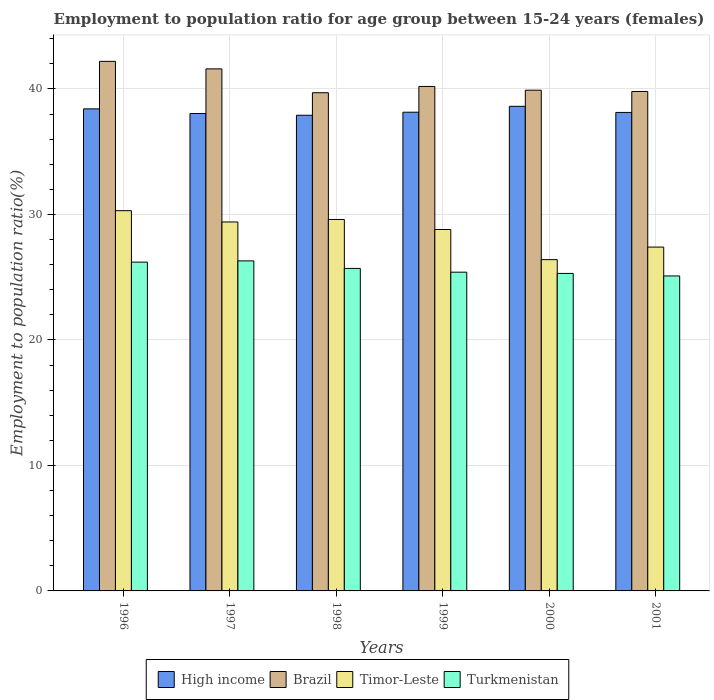How many different coloured bars are there?
Provide a short and direct response. 4. How many groups of bars are there?
Your answer should be very brief. 6. Are the number of bars on each tick of the X-axis equal?
Keep it short and to the point. Yes. How many bars are there on the 5th tick from the right?
Offer a terse response. 4. What is the employment to population ratio in Brazil in 2000?
Offer a terse response. 39.9. Across all years, what is the maximum employment to population ratio in Timor-Leste?
Offer a terse response. 30.3. Across all years, what is the minimum employment to population ratio in Timor-Leste?
Ensure brevity in your answer.  26.4. What is the total employment to population ratio in Brazil in the graph?
Ensure brevity in your answer.  243.4. What is the difference between the employment to population ratio in Turkmenistan in 1999 and that in 2001?
Give a very brief answer. 0.3. What is the difference between the employment to population ratio in High income in 2001 and the employment to population ratio in Brazil in 1999?
Your answer should be very brief. -2.07. What is the average employment to population ratio in Turkmenistan per year?
Make the answer very short. 25.67. In the year 1997, what is the difference between the employment to population ratio in Brazil and employment to population ratio in Turkmenistan?
Provide a succinct answer. 15.3. In how many years, is the employment to population ratio in Turkmenistan greater than 34 %?
Your response must be concise. 0. What is the ratio of the employment to population ratio in Timor-Leste in 1998 to that in 1999?
Ensure brevity in your answer.  1.03. Is the difference between the employment to population ratio in Brazil in 1998 and 2000 greater than the difference between the employment to population ratio in Turkmenistan in 1998 and 2000?
Give a very brief answer. No. What is the difference between the highest and the second highest employment to population ratio in Brazil?
Keep it short and to the point. 0.6. What is the difference between the highest and the lowest employment to population ratio in Brazil?
Offer a very short reply. 2.5. In how many years, is the employment to population ratio in High income greater than the average employment to population ratio in High income taken over all years?
Make the answer very short. 2. What does the 2nd bar from the right in 1999 represents?
Offer a very short reply. Timor-Leste. Are all the bars in the graph horizontal?
Ensure brevity in your answer.  No. How many years are there in the graph?
Give a very brief answer. 6. Does the graph contain grids?
Your response must be concise. Yes. Where does the legend appear in the graph?
Your response must be concise. Bottom center. How many legend labels are there?
Offer a terse response. 4. What is the title of the graph?
Your answer should be compact. Employment to population ratio for age group between 15-24 years (females). Does "Latin America(developing only)" appear as one of the legend labels in the graph?
Your response must be concise. No. What is the label or title of the X-axis?
Make the answer very short. Years. What is the label or title of the Y-axis?
Your answer should be compact. Employment to population ratio(%). What is the Employment to population ratio(%) of High income in 1996?
Your response must be concise. 38.41. What is the Employment to population ratio(%) of Brazil in 1996?
Make the answer very short. 42.2. What is the Employment to population ratio(%) of Timor-Leste in 1996?
Give a very brief answer. 30.3. What is the Employment to population ratio(%) in Turkmenistan in 1996?
Provide a short and direct response. 26.2. What is the Employment to population ratio(%) of High income in 1997?
Provide a short and direct response. 38.04. What is the Employment to population ratio(%) in Brazil in 1997?
Your answer should be very brief. 41.6. What is the Employment to population ratio(%) of Timor-Leste in 1997?
Your answer should be compact. 29.4. What is the Employment to population ratio(%) of Turkmenistan in 1997?
Your answer should be compact. 26.3. What is the Employment to population ratio(%) in High income in 1998?
Provide a short and direct response. 37.9. What is the Employment to population ratio(%) in Brazil in 1998?
Give a very brief answer. 39.7. What is the Employment to population ratio(%) of Timor-Leste in 1998?
Offer a terse response. 29.6. What is the Employment to population ratio(%) of Turkmenistan in 1998?
Keep it short and to the point. 25.7. What is the Employment to population ratio(%) in High income in 1999?
Offer a terse response. 38.15. What is the Employment to population ratio(%) in Brazil in 1999?
Offer a terse response. 40.2. What is the Employment to population ratio(%) in Timor-Leste in 1999?
Make the answer very short. 28.8. What is the Employment to population ratio(%) in Turkmenistan in 1999?
Offer a very short reply. 25.4. What is the Employment to population ratio(%) of High income in 2000?
Your answer should be very brief. 38.62. What is the Employment to population ratio(%) in Brazil in 2000?
Provide a short and direct response. 39.9. What is the Employment to population ratio(%) in Timor-Leste in 2000?
Offer a very short reply. 26.4. What is the Employment to population ratio(%) of Turkmenistan in 2000?
Make the answer very short. 25.3. What is the Employment to population ratio(%) in High income in 2001?
Your answer should be compact. 38.13. What is the Employment to population ratio(%) of Brazil in 2001?
Your response must be concise. 39.8. What is the Employment to population ratio(%) in Timor-Leste in 2001?
Provide a succinct answer. 27.4. What is the Employment to population ratio(%) of Turkmenistan in 2001?
Provide a succinct answer. 25.1. Across all years, what is the maximum Employment to population ratio(%) of High income?
Ensure brevity in your answer.  38.62. Across all years, what is the maximum Employment to population ratio(%) in Brazil?
Make the answer very short. 42.2. Across all years, what is the maximum Employment to population ratio(%) of Timor-Leste?
Make the answer very short. 30.3. Across all years, what is the maximum Employment to population ratio(%) in Turkmenistan?
Your response must be concise. 26.3. Across all years, what is the minimum Employment to population ratio(%) of High income?
Provide a short and direct response. 37.9. Across all years, what is the minimum Employment to population ratio(%) of Brazil?
Your answer should be very brief. 39.7. Across all years, what is the minimum Employment to population ratio(%) in Timor-Leste?
Your answer should be very brief. 26.4. Across all years, what is the minimum Employment to population ratio(%) of Turkmenistan?
Ensure brevity in your answer.  25.1. What is the total Employment to population ratio(%) of High income in the graph?
Offer a terse response. 229.26. What is the total Employment to population ratio(%) of Brazil in the graph?
Make the answer very short. 243.4. What is the total Employment to population ratio(%) of Timor-Leste in the graph?
Offer a very short reply. 171.9. What is the total Employment to population ratio(%) of Turkmenistan in the graph?
Your response must be concise. 154. What is the difference between the Employment to population ratio(%) of High income in 1996 and that in 1997?
Provide a succinct answer. 0.37. What is the difference between the Employment to population ratio(%) of Timor-Leste in 1996 and that in 1997?
Offer a terse response. 0.9. What is the difference between the Employment to population ratio(%) in Turkmenistan in 1996 and that in 1997?
Your answer should be very brief. -0.1. What is the difference between the Employment to population ratio(%) in High income in 1996 and that in 1998?
Offer a terse response. 0.51. What is the difference between the Employment to population ratio(%) of Turkmenistan in 1996 and that in 1998?
Offer a terse response. 0.5. What is the difference between the Employment to population ratio(%) of High income in 1996 and that in 1999?
Provide a short and direct response. 0.27. What is the difference between the Employment to population ratio(%) of Timor-Leste in 1996 and that in 1999?
Keep it short and to the point. 1.5. What is the difference between the Employment to population ratio(%) of High income in 1996 and that in 2000?
Provide a short and direct response. -0.2. What is the difference between the Employment to population ratio(%) of Brazil in 1996 and that in 2000?
Offer a terse response. 2.3. What is the difference between the Employment to population ratio(%) of High income in 1996 and that in 2001?
Ensure brevity in your answer.  0.28. What is the difference between the Employment to population ratio(%) in Timor-Leste in 1996 and that in 2001?
Your response must be concise. 2.9. What is the difference between the Employment to population ratio(%) in Turkmenistan in 1996 and that in 2001?
Keep it short and to the point. 1.1. What is the difference between the Employment to population ratio(%) of High income in 1997 and that in 1998?
Offer a very short reply. 0.14. What is the difference between the Employment to population ratio(%) in High income in 1997 and that in 1999?
Keep it short and to the point. -0.1. What is the difference between the Employment to population ratio(%) of Brazil in 1997 and that in 1999?
Your answer should be compact. 1.4. What is the difference between the Employment to population ratio(%) in Timor-Leste in 1997 and that in 1999?
Make the answer very short. 0.6. What is the difference between the Employment to population ratio(%) of High income in 1997 and that in 2000?
Offer a very short reply. -0.57. What is the difference between the Employment to population ratio(%) of Timor-Leste in 1997 and that in 2000?
Your answer should be compact. 3. What is the difference between the Employment to population ratio(%) of Turkmenistan in 1997 and that in 2000?
Offer a terse response. 1. What is the difference between the Employment to population ratio(%) in High income in 1997 and that in 2001?
Your answer should be compact. -0.09. What is the difference between the Employment to population ratio(%) in Turkmenistan in 1997 and that in 2001?
Your answer should be compact. 1.2. What is the difference between the Employment to population ratio(%) of High income in 1998 and that in 1999?
Make the answer very short. -0.24. What is the difference between the Employment to population ratio(%) in Timor-Leste in 1998 and that in 1999?
Ensure brevity in your answer.  0.8. What is the difference between the Employment to population ratio(%) in High income in 1998 and that in 2000?
Give a very brief answer. -0.71. What is the difference between the Employment to population ratio(%) in High income in 1998 and that in 2001?
Your response must be concise. -0.23. What is the difference between the Employment to population ratio(%) of Timor-Leste in 1998 and that in 2001?
Offer a terse response. 2.2. What is the difference between the Employment to population ratio(%) of Turkmenistan in 1998 and that in 2001?
Your answer should be compact. 0.6. What is the difference between the Employment to population ratio(%) in High income in 1999 and that in 2000?
Keep it short and to the point. -0.47. What is the difference between the Employment to population ratio(%) in Brazil in 1999 and that in 2000?
Give a very brief answer. 0.3. What is the difference between the Employment to population ratio(%) of High income in 1999 and that in 2001?
Make the answer very short. 0.02. What is the difference between the Employment to population ratio(%) of Brazil in 1999 and that in 2001?
Make the answer very short. 0.4. What is the difference between the Employment to population ratio(%) of Timor-Leste in 1999 and that in 2001?
Offer a terse response. 1.4. What is the difference between the Employment to population ratio(%) of High income in 2000 and that in 2001?
Provide a succinct answer. 0.49. What is the difference between the Employment to population ratio(%) in Brazil in 2000 and that in 2001?
Provide a succinct answer. 0.1. What is the difference between the Employment to population ratio(%) in Turkmenistan in 2000 and that in 2001?
Your response must be concise. 0.2. What is the difference between the Employment to population ratio(%) in High income in 1996 and the Employment to population ratio(%) in Brazil in 1997?
Give a very brief answer. -3.19. What is the difference between the Employment to population ratio(%) in High income in 1996 and the Employment to population ratio(%) in Timor-Leste in 1997?
Your response must be concise. 9.01. What is the difference between the Employment to population ratio(%) in High income in 1996 and the Employment to population ratio(%) in Turkmenistan in 1997?
Provide a short and direct response. 12.11. What is the difference between the Employment to population ratio(%) in Brazil in 1996 and the Employment to population ratio(%) in Turkmenistan in 1997?
Your answer should be very brief. 15.9. What is the difference between the Employment to population ratio(%) in High income in 1996 and the Employment to population ratio(%) in Brazil in 1998?
Offer a terse response. -1.29. What is the difference between the Employment to population ratio(%) of High income in 1996 and the Employment to population ratio(%) of Timor-Leste in 1998?
Offer a very short reply. 8.81. What is the difference between the Employment to population ratio(%) of High income in 1996 and the Employment to population ratio(%) of Turkmenistan in 1998?
Give a very brief answer. 12.71. What is the difference between the Employment to population ratio(%) of Brazil in 1996 and the Employment to population ratio(%) of Timor-Leste in 1998?
Offer a very short reply. 12.6. What is the difference between the Employment to population ratio(%) of Brazil in 1996 and the Employment to population ratio(%) of Turkmenistan in 1998?
Give a very brief answer. 16.5. What is the difference between the Employment to population ratio(%) of Timor-Leste in 1996 and the Employment to population ratio(%) of Turkmenistan in 1998?
Provide a short and direct response. 4.6. What is the difference between the Employment to population ratio(%) of High income in 1996 and the Employment to population ratio(%) of Brazil in 1999?
Your answer should be compact. -1.79. What is the difference between the Employment to population ratio(%) in High income in 1996 and the Employment to population ratio(%) in Timor-Leste in 1999?
Your answer should be very brief. 9.61. What is the difference between the Employment to population ratio(%) of High income in 1996 and the Employment to population ratio(%) of Turkmenistan in 1999?
Offer a very short reply. 13.01. What is the difference between the Employment to population ratio(%) in Brazil in 1996 and the Employment to population ratio(%) in Timor-Leste in 1999?
Provide a succinct answer. 13.4. What is the difference between the Employment to population ratio(%) of Timor-Leste in 1996 and the Employment to population ratio(%) of Turkmenistan in 1999?
Ensure brevity in your answer.  4.9. What is the difference between the Employment to population ratio(%) in High income in 1996 and the Employment to population ratio(%) in Brazil in 2000?
Your answer should be very brief. -1.49. What is the difference between the Employment to population ratio(%) in High income in 1996 and the Employment to population ratio(%) in Timor-Leste in 2000?
Offer a very short reply. 12.01. What is the difference between the Employment to population ratio(%) in High income in 1996 and the Employment to population ratio(%) in Turkmenistan in 2000?
Provide a succinct answer. 13.11. What is the difference between the Employment to population ratio(%) in Brazil in 1996 and the Employment to population ratio(%) in Timor-Leste in 2000?
Make the answer very short. 15.8. What is the difference between the Employment to population ratio(%) in High income in 1996 and the Employment to population ratio(%) in Brazil in 2001?
Provide a succinct answer. -1.39. What is the difference between the Employment to population ratio(%) in High income in 1996 and the Employment to population ratio(%) in Timor-Leste in 2001?
Ensure brevity in your answer.  11.01. What is the difference between the Employment to population ratio(%) of High income in 1996 and the Employment to population ratio(%) of Turkmenistan in 2001?
Ensure brevity in your answer.  13.31. What is the difference between the Employment to population ratio(%) in Brazil in 1996 and the Employment to population ratio(%) in Timor-Leste in 2001?
Offer a terse response. 14.8. What is the difference between the Employment to population ratio(%) of Brazil in 1996 and the Employment to population ratio(%) of Turkmenistan in 2001?
Your response must be concise. 17.1. What is the difference between the Employment to population ratio(%) in High income in 1997 and the Employment to population ratio(%) in Brazil in 1998?
Your answer should be compact. -1.66. What is the difference between the Employment to population ratio(%) of High income in 1997 and the Employment to population ratio(%) of Timor-Leste in 1998?
Offer a very short reply. 8.44. What is the difference between the Employment to population ratio(%) of High income in 1997 and the Employment to population ratio(%) of Turkmenistan in 1998?
Make the answer very short. 12.34. What is the difference between the Employment to population ratio(%) of Brazil in 1997 and the Employment to population ratio(%) of Turkmenistan in 1998?
Keep it short and to the point. 15.9. What is the difference between the Employment to population ratio(%) of High income in 1997 and the Employment to population ratio(%) of Brazil in 1999?
Offer a very short reply. -2.16. What is the difference between the Employment to population ratio(%) of High income in 1997 and the Employment to population ratio(%) of Timor-Leste in 1999?
Make the answer very short. 9.24. What is the difference between the Employment to population ratio(%) in High income in 1997 and the Employment to population ratio(%) in Turkmenistan in 1999?
Provide a succinct answer. 12.64. What is the difference between the Employment to population ratio(%) of Brazil in 1997 and the Employment to population ratio(%) of Turkmenistan in 1999?
Give a very brief answer. 16.2. What is the difference between the Employment to population ratio(%) in High income in 1997 and the Employment to population ratio(%) in Brazil in 2000?
Your answer should be very brief. -1.86. What is the difference between the Employment to population ratio(%) of High income in 1997 and the Employment to population ratio(%) of Timor-Leste in 2000?
Give a very brief answer. 11.64. What is the difference between the Employment to population ratio(%) in High income in 1997 and the Employment to population ratio(%) in Turkmenistan in 2000?
Provide a short and direct response. 12.74. What is the difference between the Employment to population ratio(%) in Brazil in 1997 and the Employment to population ratio(%) in Timor-Leste in 2000?
Provide a short and direct response. 15.2. What is the difference between the Employment to population ratio(%) in Brazil in 1997 and the Employment to population ratio(%) in Turkmenistan in 2000?
Keep it short and to the point. 16.3. What is the difference between the Employment to population ratio(%) of High income in 1997 and the Employment to population ratio(%) of Brazil in 2001?
Your answer should be compact. -1.76. What is the difference between the Employment to population ratio(%) of High income in 1997 and the Employment to population ratio(%) of Timor-Leste in 2001?
Ensure brevity in your answer.  10.64. What is the difference between the Employment to population ratio(%) of High income in 1997 and the Employment to population ratio(%) of Turkmenistan in 2001?
Keep it short and to the point. 12.94. What is the difference between the Employment to population ratio(%) in Brazil in 1997 and the Employment to population ratio(%) in Timor-Leste in 2001?
Your answer should be very brief. 14.2. What is the difference between the Employment to population ratio(%) in Timor-Leste in 1997 and the Employment to population ratio(%) in Turkmenistan in 2001?
Offer a terse response. 4.3. What is the difference between the Employment to population ratio(%) in High income in 1998 and the Employment to population ratio(%) in Brazil in 1999?
Provide a succinct answer. -2.3. What is the difference between the Employment to population ratio(%) in High income in 1998 and the Employment to population ratio(%) in Timor-Leste in 1999?
Offer a very short reply. 9.1. What is the difference between the Employment to population ratio(%) of High income in 1998 and the Employment to population ratio(%) of Turkmenistan in 1999?
Your answer should be very brief. 12.5. What is the difference between the Employment to population ratio(%) of Brazil in 1998 and the Employment to population ratio(%) of Timor-Leste in 1999?
Ensure brevity in your answer.  10.9. What is the difference between the Employment to population ratio(%) in Brazil in 1998 and the Employment to population ratio(%) in Turkmenistan in 1999?
Your answer should be very brief. 14.3. What is the difference between the Employment to population ratio(%) of High income in 1998 and the Employment to population ratio(%) of Brazil in 2000?
Your response must be concise. -2. What is the difference between the Employment to population ratio(%) in High income in 1998 and the Employment to population ratio(%) in Timor-Leste in 2000?
Offer a very short reply. 11.5. What is the difference between the Employment to population ratio(%) in High income in 1998 and the Employment to population ratio(%) in Turkmenistan in 2000?
Keep it short and to the point. 12.6. What is the difference between the Employment to population ratio(%) in High income in 1998 and the Employment to population ratio(%) in Brazil in 2001?
Your answer should be compact. -1.9. What is the difference between the Employment to population ratio(%) in High income in 1998 and the Employment to population ratio(%) in Timor-Leste in 2001?
Offer a terse response. 10.5. What is the difference between the Employment to population ratio(%) of High income in 1998 and the Employment to population ratio(%) of Turkmenistan in 2001?
Provide a succinct answer. 12.8. What is the difference between the Employment to population ratio(%) of High income in 1999 and the Employment to population ratio(%) of Brazil in 2000?
Ensure brevity in your answer.  -1.75. What is the difference between the Employment to population ratio(%) in High income in 1999 and the Employment to population ratio(%) in Timor-Leste in 2000?
Provide a short and direct response. 11.75. What is the difference between the Employment to population ratio(%) in High income in 1999 and the Employment to population ratio(%) in Turkmenistan in 2000?
Offer a terse response. 12.85. What is the difference between the Employment to population ratio(%) in High income in 1999 and the Employment to population ratio(%) in Brazil in 2001?
Your answer should be very brief. -1.65. What is the difference between the Employment to population ratio(%) of High income in 1999 and the Employment to population ratio(%) of Timor-Leste in 2001?
Offer a very short reply. 10.75. What is the difference between the Employment to population ratio(%) in High income in 1999 and the Employment to population ratio(%) in Turkmenistan in 2001?
Make the answer very short. 13.05. What is the difference between the Employment to population ratio(%) in Brazil in 1999 and the Employment to population ratio(%) in Timor-Leste in 2001?
Offer a very short reply. 12.8. What is the difference between the Employment to population ratio(%) in Brazil in 1999 and the Employment to population ratio(%) in Turkmenistan in 2001?
Make the answer very short. 15.1. What is the difference between the Employment to population ratio(%) of Timor-Leste in 1999 and the Employment to population ratio(%) of Turkmenistan in 2001?
Your response must be concise. 3.7. What is the difference between the Employment to population ratio(%) of High income in 2000 and the Employment to population ratio(%) of Brazil in 2001?
Offer a very short reply. -1.18. What is the difference between the Employment to population ratio(%) of High income in 2000 and the Employment to population ratio(%) of Timor-Leste in 2001?
Give a very brief answer. 11.22. What is the difference between the Employment to population ratio(%) in High income in 2000 and the Employment to population ratio(%) in Turkmenistan in 2001?
Make the answer very short. 13.52. What is the difference between the Employment to population ratio(%) of Timor-Leste in 2000 and the Employment to population ratio(%) of Turkmenistan in 2001?
Offer a terse response. 1.3. What is the average Employment to population ratio(%) in High income per year?
Offer a very short reply. 38.21. What is the average Employment to population ratio(%) in Brazil per year?
Your answer should be compact. 40.57. What is the average Employment to population ratio(%) in Timor-Leste per year?
Offer a terse response. 28.65. What is the average Employment to population ratio(%) of Turkmenistan per year?
Provide a succinct answer. 25.67. In the year 1996, what is the difference between the Employment to population ratio(%) of High income and Employment to population ratio(%) of Brazil?
Provide a succinct answer. -3.79. In the year 1996, what is the difference between the Employment to population ratio(%) in High income and Employment to population ratio(%) in Timor-Leste?
Offer a terse response. 8.11. In the year 1996, what is the difference between the Employment to population ratio(%) in High income and Employment to population ratio(%) in Turkmenistan?
Offer a terse response. 12.21. In the year 1996, what is the difference between the Employment to population ratio(%) in Brazil and Employment to population ratio(%) in Timor-Leste?
Your answer should be compact. 11.9. In the year 1996, what is the difference between the Employment to population ratio(%) of Brazil and Employment to population ratio(%) of Turkmenistan?
Your answer should be compact. 16. In the year 1996, what is the difference between the Employment to population ratio(%) of Timor-Leste and Employment to population ratio(%) of Turkmenistan?
Offer a terse response. 4.1. In the year 1997, what is the difference between the Employment to population ratio(%) of High income and Employment to population ratio(%) of Brazil?
Your answer should be very brief. -3.56. In the year 1997, what is the difference between the Employment to population ratio(%) in High income and Employment to population ratio(%) in Timor-Leste?
Provide a short and direct response. 8.64. In the year 1997, what is the difference between the Employment to population ratio(%) of High income and Employment to population ratio(%) of Turkmenistan?
Offer a very short reply. 11.74. In the year 1997, what is the difference between the Employment to population ratio(%) in Brazil and Employment to population ratio(%) in Turkmenistan?
Keep it short and to the point. 15.3. In the year 1998, what is the difference between the Employment to population ratio(%) in High income and Employment to population ratio(%) in Brazil?
Provide a short and direct response. -1.8. In the year 1998, what is the difference between the Employment to population ratio(%) of High income and Employment to population ratio(%) of Timor-Leste?
Give a very brief answer. 8.3. In the year 1998, what is the difference between the Employment to population ratio(%) in High income and Employment to population ratio(%) in Turkmenistan?
Your answer should be compact. 12.2. In the year 1998, what is the difference between the Employment to population ratio(%) in Brazil and Employment to population ratio(%) in Timor-Leste?
Your response must be concise. 10.1. In the year 1998, what is the difference between the Employment to population ratio(%) of Timor-Leste and Employment to population ratio(%) of Turkmenistan?
Offer a very short reply. 3.9. In the year 1999, what is the difference between the Employment to population ratio(%) of High income and Employment to population ratio(%) of Brazil?
Provide a short and direct response. -2.05. In the year 1999, what is the difference between the Employment to population ratio(%) in High income and Employment to population ratio(%) in Timor-Leste?
Your answer should be compact. 9.35. In the year 1999, what is the difference between the Employment to population ratio(%) in High income and Employment to population ratio(%) in Turkmenistan?
Provide a short and direct response. 12.75. In the year 2000, what is the difference between the Employment to population ratio(%) in High income and Employment to population ratio(%) in Brazil?
Offer a terse response. -1.28. In the year 2000, what is the difference between the Employment to population ratio(%) of High income and Employment to population ratio(%) of Timor-Leste?
Your response must be concise. 12.22. In the year 2000, what is the difference between the Employment to population ratio(%) in High income and Employment to population ratio(%) in Turkmenistan?
Your response must be concise. 13.32. In the year 2000, what is the difference between the Employment to population ratio(%) of Brazil and Employment to population ratio(%) of Turkmenistan?
Offer a very short reply. 14.6. In the year 2000, what is the difference between the Employment to population ratio(%) of Timor-Leste and Employment to population ratio(%) of Turkmenistan?
Provide a short and direct response. 1.1. In the year 2001, what is the difference between the Employment to population ratio(%) of High income and Employment to population ratio(%) of Brazil?
Keep it short and to the point. -1.67. In the year 2001, what is the difference between the Employment to population ratio(%) in High income and Employment to population ratio(%) in Timor-Leste?
Ensure brevity in your answer.  10.73. In the year 2001, what is the difference between the Employment to population ratio(%) in High income and Employment to population ratio(%) in Turkmenistan?
Provide a short and direct response. 13.03. In the year 2001, what is the difference between the Employment to population ratio(%) of Brazil and Employment to population ratio(%) of Timor-Leste?
Ensure brevity in your answer.  12.4. What is the ratio of the Employment to population ratio(%) of High income in 1996 to that in 1997?
Give a very brief answer. 1.01. What is the ratio of the Employment to population ratio(%) in Brazil in 1996 to that in 1997?
Offer a very short reply. 1.01. What is the ratio of the Employment to population ratio(%) in Timor-Leste in 1996 to that in 1997?
Offer a very short reply. 1.03. What is the ratio of the Employment to population ratio(%) of Turkmenistan in 1996 to that in 1997?
Provide a succinct answer. 1. What is the ratio of the Employment to population ratio(%) of High income in 1996 to that in 1998?
Keep it short and to the point. 1.01. What is the ratio of the Employment to population ratio(%) in Brazil in 1996 to that in 1998?
Provide a short and direct response. 1.06. What is the ratio of the Employment to population ratio(%) of Timor-Leste in 1996 to that in 1998?
Your response must be concise. 1.02. What is the ratio of the Employment to population ratio(%) of Turkmenistan in 1996 to that in 1998?
Your response must be concise. 1.02. What is the ratio of the Employment to population ratio(%) in Brazil in 1996 to that in 1999?
Give a very brief answer. 1.05. What is the ratio of the Employment to population ratio(%) in Timor-Leste in 1996 to that in 1999?
Ensure brevity in your answer.  1.05. What is the ratio of the Employment to population ratio(%) of Turkmenistan in 1996 to that in 1999?
Provide a succinct answer. 1.03. What is the ratio of the Employment to population ratio(%) of High income in 1996 to that in 2000?
Ensure brevity in your answer.  0.99. What is the ratio of the Employment to population ratio(%) of Brazil in 1996 to that in 2000?
Provide a succinct answer. 1.06. What is the ratio of the Employment to population ratio(%) of Timor-Leste in 1996 to that in 2000?
Keep it short and to the point. 1.15. What is the ratio of the Employment to population ratio(%) in Turkmenistan in 1996 to that in 2000?
Ensure brevity in your answer.  1.04. What is the ratio of the Employment to population ratio(%) of High income in 1996 to that in 2001?
Your answer should be very brief. 1.01. What is the ratio of the Employment to population ratio(%) in Brazil in 1996 to that in 2001?
Keep it short and to the point. 1.06. What is the ratio of the Employment to population ratio(%) of Timor-Leste in 1996 to that in 2001?
Your response must be concise. 1.11. What is the ratio of the Employment to population ratio(%) of Turkmenistan in 1996 to that in 2001?
Your response must be concise. 1.04. What is the ratio of the Employment to population ratio(%) in Brazil in 1997 to that in 1998?
Your response must be concise. 1.05. What is the ratio of the Employment to population ratio(%) in Timor-Leste in 1997 to that in 1998?
Offer a very short reply. 0.99. What is the ratio of the Employment to population ratio(%) in Turkmenistan in 1997 to that in 1998?
Make the answer very short. 1.02. What is the ratio of the Employment to population ratio(%) in High income in 1997 to that in 1999?
Your answer should be compact. 1. What is the ratio of the Employment to population ratio(%) in Brazil in 1997 to that in 1999?
Provide a short and direct response. 1.03. What is the ratio of the Employment to population ratio(%) in Timor-Leste in 1997 to that in 1999?
Provide a short and direct response. 1.02. What is the ratio of the Employment to population ratio(%) in Turkmenistan in 1997 to that in 1999?
Offer a terse response. 1.04. What is the ratio of the Employment to population ratio(%) in High income in 1997 to that in 2000?
Your answer should be compact. 0.99. What is the ratio of the Employment to population ratio(%) of Brazil in 1997 to that in 2000?
Offer a very short reply. 1.04. What is the ratio of the Employment to population ratio(%) of Timor-Leste in 1997 to that in 2000?
Ensure brevity in your answer.  1.11. What is the ratio of the Employment to population ratio(%) of Turkmenistan in 1997 to that in 2000?
Ensure brevity in your answer.  1.04. What is the ratio of the Employment to population ratio(%) of High income in 1997 to that in 2001?
Your answer should be very brief. 1. What is the ratio of the Employment to population ratio(%) of Brazil in 1997 to that in 2001?
Give a very brief answer. 1.05. What is the ratio of the Employment to population ratio(%) of Timor-Leste in 1997 to that in 2001?
Your answer should be very brief. 1.07. What is the ratio of the Employment to population ratio(%) of Turkmenistan in 1997 to that in 2001?
Make the answer very short. 1.05. What is the ratio of the Employment to population ratio(%) in High income in 1998 to that in 1999?
Your response must be concise. 0.99. What is the ratio of the Employment to population ratio(%) in Brazil in 1998 to that in 1999?
Provide a succinct answer. 0.99. What is the ratio of the Employment to population ratio(%) of Timor-Leste in 1998 to that in 1999?
Offer a terse response. 1.03. What is the ratio of the Employment to population ratio(%) in Turkmenistan in 1998 to that in 1999?
Your response must be concise. 1.01. What is the ratio of the Employment to population ratio(%) of High income in 1998 to that in 2000?
Your response must be concise. 0.98. What is the ratio of the Employment to population ratio(%) in Timor-Leste in 1998 to that in 2000?
Provide a short and direct response. 1.12. What is the ratio of the Employment to population ratio(%) of Turkmenistan in 1998 to that in 2000?
Provide a succinct answer. 1.02. What is the ratio of the Employment to population ratio(%) of Brazil in 1998 to that in 2001?
Offer a very short reply. 1. What is the ratio of the Employment to population ratio(%) of Timor-Leste in 1998 to that in 2001?
Provide a succinct answer. 1.08. What is the ratio of the Employment to population ratio(%) of Turkmenistan in 1998 to that in 2001?
Offer a terse response. 1.02. What is the ratio of the Employment to population ratio(%) of High income in 1999 to that in 2000?
Your answer should be compact. 0.99. What is the ratio of the Employment to population ratio(%) of Brazil in 1999 to that in 2000?
Offer a terse response. 1.01. What is the ratio of the Employment to population ratio(%) of Timor-Leste in 1999 to that in 2001?
Ensure brevity in your answer.  1.05. What is the ratio of the Employment to population ratio(%) in Turkmenistan in 1999 to that in 2001?
Provide a succinct answer. 1.01. What is the ratio of the Employment to population ratio(%) in High income in 2000 to that in 2001?
Give a very brief answer. 1.01. What is the ratio of the Employment to population ratio(%) in Brazil in 2000 to that in 2001?
Your response must be concise. 1. What is the ratio of the Employment to population ratio(%) of Timor-Leste in 2000 to that in 2001?
Your answer should be compact. 0.96. What is the ratio of the Employment to population ratio(%) of Turkmenistan in 2000 to that in 2001?
Ensure brevity in your answer.  1.01. What is the difference between the highest and the second highest Employment to population ratio(%) of High income?
Ensure brevity in your answer.  0.2. What is the difference between the highest and the lowest Employment to population ratio(%) in High income?
Ensure brevity in your answer.  0.71. What is the difference between the highest and the lowest Employment to population ratio(%) in Turkmenistan?
Make the answer very short. 1.2. 